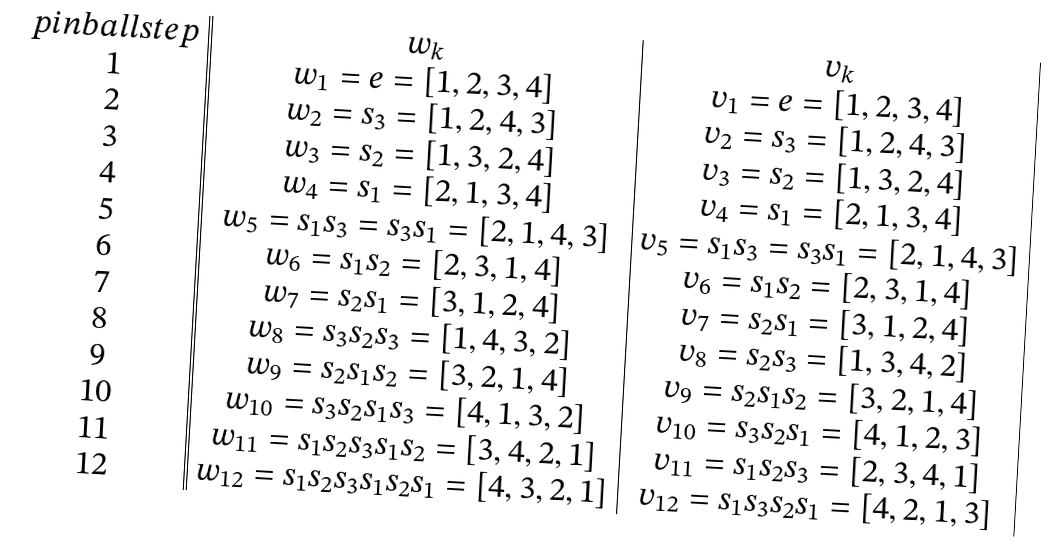<formula> <loc_0><loc_0><loc_500><loc_500>\begin{array} { c | | c | c | } p i n b a l l s t e p & w _ { k } & v _ { k } \\ 1 & w _ { 1 } = e = [ 1 , 2 , 3 , 4 ] & v _ { 1 } = e = [ 1 , 2 , 3 , 4 ] \\ 2 & w _ { 2 } = s _ { 3 } = [ 1 , 2 , 4 , 3 ] & v _ { 2 } = s _ { 3 } = [ 1 , 2 , 4 , 3 ] \\ 3 & w _ { 3 } = s _ { 2 } = [ 1 , 3 , 2 , 4 ] & v _ { 3 } = s _ { 2 } = [ 1 , 3 , 2 , 4 ] \\ 4 & w _ { 4 } = s _ { 1 } = [ 2 , 1 , 3 , 4 ] & v _ { 4 } = s _ { 1 } = [ 2 , 1 , 3 , 4 ] \\ 5 & w _ { 5 } = s _ { 1 } s _ { 3 } = s _ { 3 } s _ { 1 } = [ 2 , 1 , 4 , 3 ] & v _ { 5 } = s _ { 1 } s _ { 3 } = s _ { 3 } s _ { 1 } = [ 2 , 1 , 4 , 3 ] \\ 6 & w _ { 6 } = s _ { 1 } s _ { 2 } = [ 2 , 3 , 1 , 4 ] & v _ { 6 } = s _ { 1 } s _ { 2 } = [ 2 , 3 , 1 , 4 ] \\ 7 & w _ { 7 } = s _ { 2 } s _ { 1 } = [ 3 , 1 , 2 , 4 ] & v _ { 7 } = s _ { 2 } s _ { 1 } = [ 3 , 1 , 2 , 4 ] \\ 8 & w _ { 8 } = s _ { 3 } s _ { 2 } s _ { 3 } = [ 1 , 4 , 3 , 2 ] & v _ { 8 } = s _ { 2 } s _ { 3 } = [ 1 , 3 , 4 , 2 ] \\ 9 & w _ { 9 } = s _ { 2 } s _ { 1 } s _ { 2 } = [ 3 , 2 , 1 , 4 ] & v _ { 9 } = s _ { 2 } s _ { 1 } s _ { 2 } = [ 3 , 2 , 1 , 4 ] \\ 1 0 & w _ { 1 0 } = s _ { 3 } s _ { 2 } s _ { 1 } s _ { 3 } = [ 4 , 1 , 3 , 2 ] & v _ { 1 0 } = s _ { 3 } s _ { 2 } s _ { 1 } = [ 4 , 1 , 2 , 3 ] \\ 1 1 & w _ { 1 1 } = s _ { 1 } s _ { 2 } s _ { 3 } s _ { 1 } s _ { 2 } = [ 3 , 4 , 2 , 1 ] & v _ { 1 1 } = s _ { 1 } s _ { 2 } s _ { 3 } = [ 2 , 3 , 4 , 1 ] \\ 1 2 & w _ { 1 2 } = s _ { 1 } s _ { 2 } s _ { 3 } s _ { 1 } s _ { 2 } s _ { 1 } = [ 4 , 3 , 2 , 1 ] & v _ { 1 2 } = s _ { 1 } s _ { 3 } s _ { 2 } s _ { 1 } = [ 4 , 2 , 1 , 3 ] \\ \end{array}</formula> 